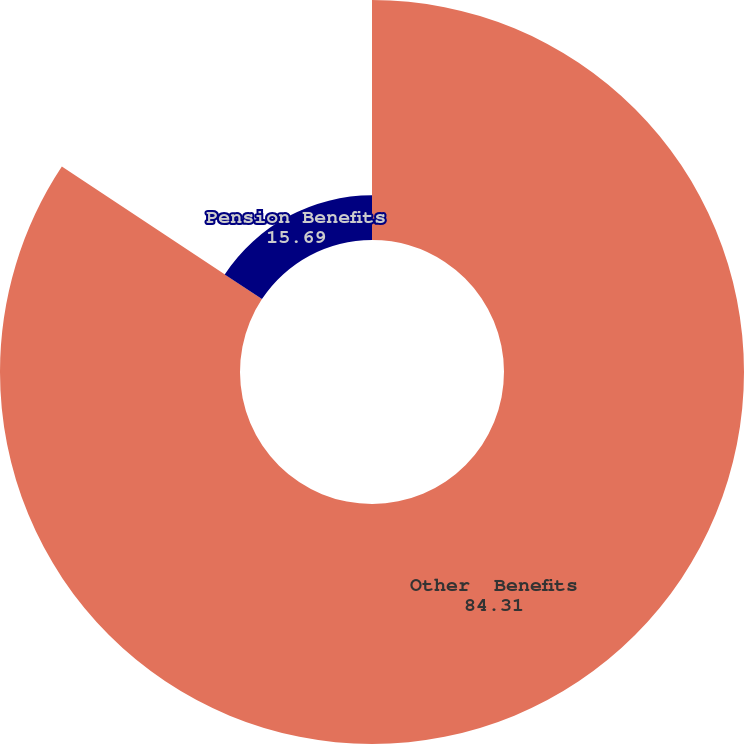Convert chart. <chart><loc_0><loc_0><loc_500><loc_500><pie_chart><fcel>Other  Benefits<fcel>Pension Benefits<nl><fcel>84.31%<fcel>15.69%<nl></chart> 